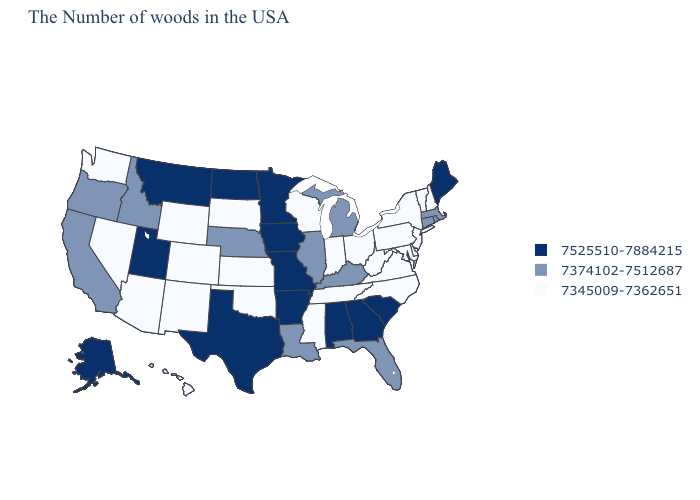Which states hav the highest value in the West?
Quick response, please. Utah, Montana, Alaska. What is the lowest value in states that border West Virginia?
Give a very brief answer. 7345009-7362651. Among the states that border Missouri , does Tennessee have the lowest value?
Answer briefly. Yes. Name the states that have a value in the range 7525510-7884215?
Write a very short answer. Maine, South Carolina, Georgia, Alabama, Missouri, Arkansas, Minnesota, Iowa, Texas, North Dakota, Utah, Montana, Alaska. Does the first symbol in the legend represent the smallest category?
Write a very short answer. No. What is the value of Washington?
Write a very short answer. 7345009-7362651. Among the states that border Wyoming , which have the lowest value?
Give a very brief answer. South Dakota, Colorado. Which states have the lowest value in the South?
Answer briefly. Delaware, Maryland, Virginia, North Carolina, West Virginia, Tennessee, Mississippi, Oklahoma. Among the states that border Georgia , does Alabama have the lowest value?
Write a very short answer. No. How many symbols are there in the legend?
Give a very brief answer. 3. What is the lowest value in the USA?
Write a very short answer. 7345009-7362651. Does the first symbol in the legend represent the smallest category?
Give a very brief answer. No. What is the highest value in the MidWest ?
Concise answer only. 7525510-7884215. What is the lowest value in the USA?
Concise answer only. 7345009-7362651. What is the value of Connecticut?
Keep it brief. 7374102-7512687. 